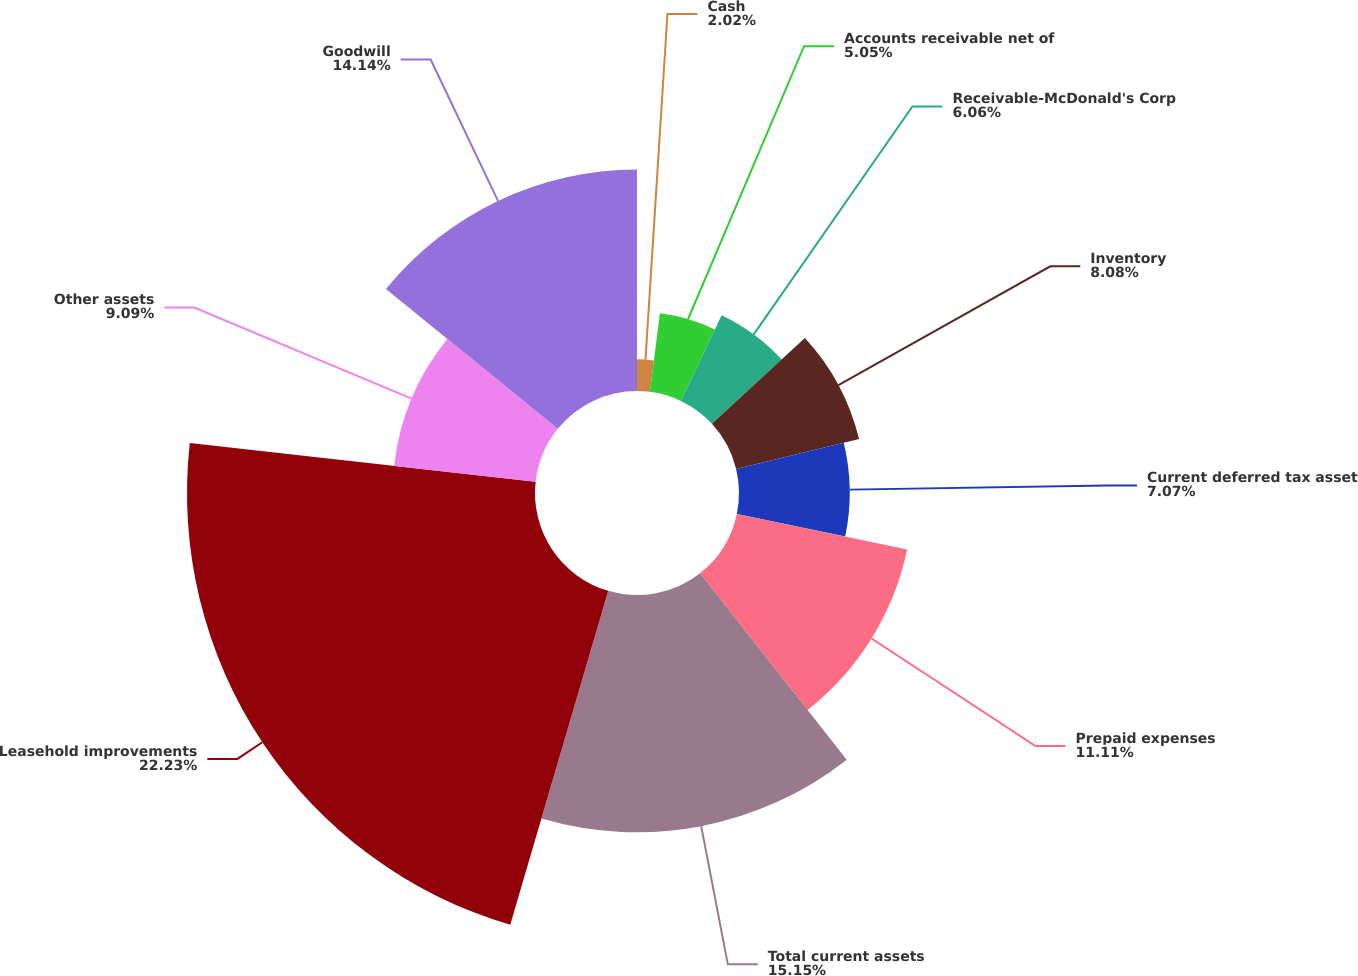Convert chart. <chart><loc_0><loc_0><loc_500><loc_500><pie_chart><fcel>Cash<fcel>Accounts receivable net of<fcel>Receivable-McDonald's Corp<fcel>Inventory<fcel>Current deferred tax asset<fcel>Prepaid expenses<fcel>Total current assets<fcel>Leasehold improvements<fcel>Other assets<fcel>Goodwill<nl><fcel>2.02%<fcel>5.05%<fcel>6.06%<fcel>8.08%<fcel>7.07%<fcel>11.11%<fcel>15.15%<fcel>22.22%<fcel>9.09%<fcel>14.14%<nl></chart> 